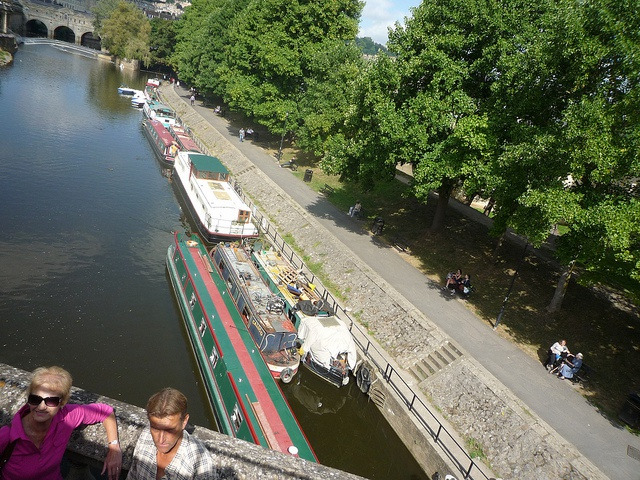Describe the objects in this image and their specific colors. I can see boat in black, teal, and salmon tones, people in black, purple, and brown tones, boat in black, gray, darkgray, and lightgray tones, boat in black, white, gray, teal, and darkgray tones, and boat in black, ivory, gray, darkgray, and tan tones in this image. 